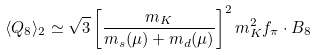Convert formula to latex. <formula><loc_0><loc_0><loc_500><loc_500>\langle Q _ { 8 } \rangle _ { 2 } \simeq \sqrt { 3 } \left [ \frac { m _ { K } } { m _ { s } ( \mu ) + m _ { d } ( \mu ) } \right ] ^ { 2 } m ^ { 2 } _ { K } f _ { \pi } \cdot B _ { 8 }</formula> 